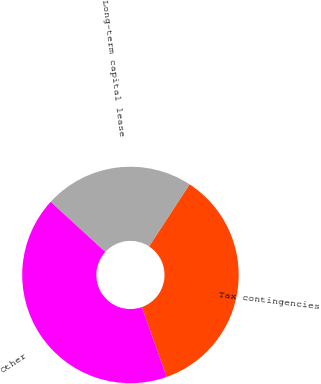Convert chart to OTSL. <chart><loc_0><loc_0><loc_500><loc_500><pie_chart><fcel>Tax contingencies<fcel>Long-term capital lease<fcel>Other<nl><fcel>35.38%<fcel>22.38%<fcel>42.24%<nl></chart> 